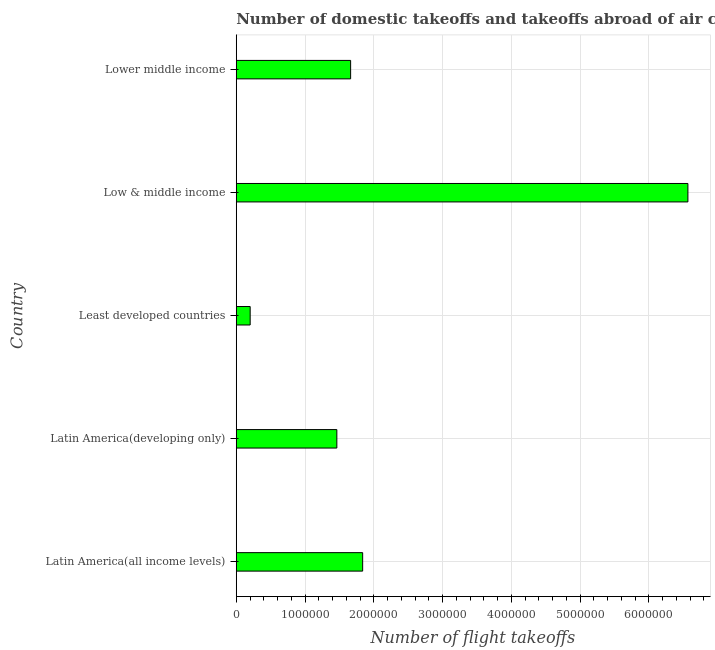Does the graph contain grids?
Provide a short and direct response. Yes. What is the title of the graph?
Provide a succinct answer. Number of domestic takeoffs and takeoffs abroad of air carriers registered in countries. What is the label or title of the X-axis?
Give a very brief answer. Number of flight takeoffs. What is the label or title of the Y-axis?
Provide a succinct answer. Country. What is the number of flight takeoffs in Lower middle income?
Your answer should be compact. 1.66e+06. Across all countries, what is the maximum number of flight takeoffs?
Keep it short and to the point. 6.57e+06. Across all countries, what is the minimum number of flight takeoffs?
Offer a very short reply. 2.02e+05. In which country was the number of flight takeoffs minimum?
Keep it short and to the point. Least developed countries. What is the sum of the number of flight takeoffs?
Ensure brevity in your answer.  1.17e+07. What is the difference between the number of flight takeoffs in Latin America(all income levels) and Lower middle income?
Ensure brevity in your answer.  1.75e+05. What is the average number of flight takeoffs per country?
Provide a short and direct response. 2.35e+06. What is the median number of flight takeoffs?
Provide a succinct answer. 1.66e+06. What is the ratio of the number of flight takeoffs in Low & middle income to that in Lower middle income?
Give a very brief answer. 3.95. Is the number of flight takeoffs in Least developed countries less than that in Lower middle income?
Keep it short and to the point. Yes. What is the difference between the highest and the second highest number of flight takeoffs?
Ensure brevity in your answer.  4.73e+06. What is the difference between the highest and the lowest number of flight takeoffs?
Your answer should be very brief. 6.37e+06. How many bars are there?
Give a very brief answer. 5. What is the Number of flight takeoffs of Latin America(all income levels)?
Give a very brief answer. 1.84e+06. What is the Number of flight takeoffs in Latin America(developing only)?
Keep it short and to the point. 1.46e+06. What is the Number of flight takeoffs in Least developed countries?
Offer a very short reply. 2.02e+05. What is the Number of flight takeoffs in Low & middle income?
Provide a short and direct response. 6.57e+06. What is the Number of flight takeoffs of Lower middle income?
Provide a succinct answer. 1.66e+06. What is the difference between the Number of flight takeoffs in Latin America(all income levels) and Latin America(developing only)?
Offer a very short reply. 3.75e+05. What is the difference between the Number of flight takeoffs in Latin America(all income levels) and Least developed countries?
Provide a short and direct response. 1.64e+06. What is the difference between the Number of flight takeoffs in Latin America(all income levels) and Low & middle income?
Provide a succinct answer. -4.73e+06. What is the difference between the Number of flight takeoffs in Latin America(all income levels) and Lower middle income?
Offer a very short reply. 1.75e+05. What is the difference between the Number of flight takeoffs in Latin America(developing only) and Least developed countries?
Ensure brevity in your answer.  1.26e+06. What is the difference between the Number of flight takeoffs in Latin America(developing only) and Low & middle income?
Keep it short and to the point. -5.11e+06. What is the difference between the Number of flight takeoffs in Latin America(developing only) and Lower middle income?
Your answer should be compact. -2.01e+05. What is the difference between the Number of flight takeoffs in Least developed countries and Low & middle income?
Keep it short and to the point. -6.37e+06. What is the difference between the Number of flight takeoffs in Least developed countries and Lower middle income?
Provide a succinct answer. -1.46e+06. What is the difference between the Number of flight takeoffs in Low & middle income and Lower middle income?
Offer a terse response. 4.91e+06. What is the ratio of the Number of flight takeoffs in Latin America(all income levels) to that in Latin America(developing only)?
Give a very brief answer. 1.26. What is the ratio of the Number of flight takeoffs in Latin America(all income levels) to that in Least developed countries?
Your answer should be compact. 9.08. What is the ratio of the Number of flight takeoffs in Latin America(all income levels) to that in Low & middle income?
Provide a short and direct response. 0.28. What is the ratio of the Number of flight takeoffs in Latin America(all income levels) to that in Lower middle income?
Provide a succinct answer. 1.1. What is the ratio of the Number of flight takeoffs in Latin America(developing only) to that in Least developed countries?
Your answer should be very brief. 7.23. What is the ratio of the Number of flight takeoffs in Latin America(developing only) to that in Low & middle income?
Provide a short and direct response. 0.22. What is the ratio of the Number of flight takeoffs in Latin America(developing only) to that in Lower middle income?
Give a very brief answer. 0.88. What is the ratio of the Number of flight takeoffs in Least developed countries to that in Low & middle income?
Provide a short and direct response. 0.03. What is the ratio of the Number of flight takeoffs in Least developed countries to that in Lower middle income?
Your response must be concise. 0.12. What is the ratio of the Number of flight takeoffs in Low & middle income to that in Lower middle income?
Give a very brief answer. 3.95. 